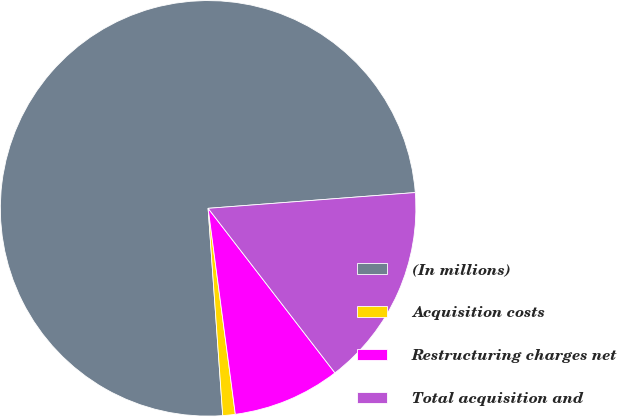Convert chart to OTSL. <chart><loc_0><loc_0><loc_500><loc_500><pie_chart><fcel>(In millions)<fcel>Acquisition costs<fcel>Restructuring charges net<fcel>Total acquisition and<nl><fcel>74.91%<fcel>0.97%<fcel>8.36%<fcel>15.76%<nl></chart> 